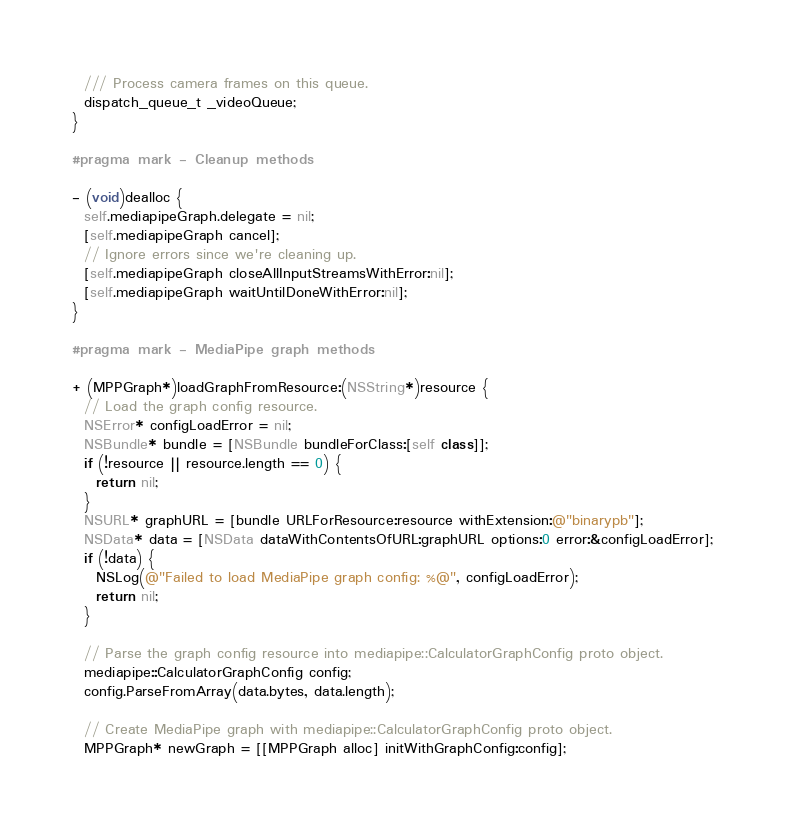<code> <loc_0><loc_0><loc_500><loc_500><_ObjectiveC_>
  /// Process camera frames on this queue.
  dispatch_queue_t _videoQueue;
}

#pragma mark - Cleanup methods

- (void)dealloc {
  self.mediapipeGraph.delegate = nil;
  [self.mediapipeGraph cancel];
  // Ignore errors since we're cleaning up.
  [self.mediapipeGraph closeAllInputStreamsWithError:nil];
  [self.mediapipeGraph waitUntilDoneWithError:nil];
}

#pragma mark - MediaPipe graph methods

+ (MPPGraph*)loadGraphFromResource:(NSString*)resource {
  // Load the graph config resource.
  NSError* configLoadError = nil;
  NSBundle* bundle = [NSBundle bundleForClass:[self class]];
  if (!resource || resource.length == 0) {
    return nil;
  }
  NSURL* graphURL = [bundle URLForResource:resource withExtension:@"binarypb"];
  NSData* data = [NSData dataWithContentsOfURL:graphURL options:0 error:&configLoadError];
  if (!data) {
    NSLog(@"Failed to load MediaPipe graph config: %@", configLoadError);
    return nil;
  }

  // Parse the graph config resource into mediapipe::CalculatorGraphConfig proto object.
  mediapipe::CalculatorGraphConfig config;
  config.ParseFromArray(data.bytes, data.length);

  // Create MediaPipe graph with mediapipe::CalculatorGraphConfig proto object.
  MPPGraph* newGraph = [[MPPGraph alloc] initWithGraphConfig:config];</code> 